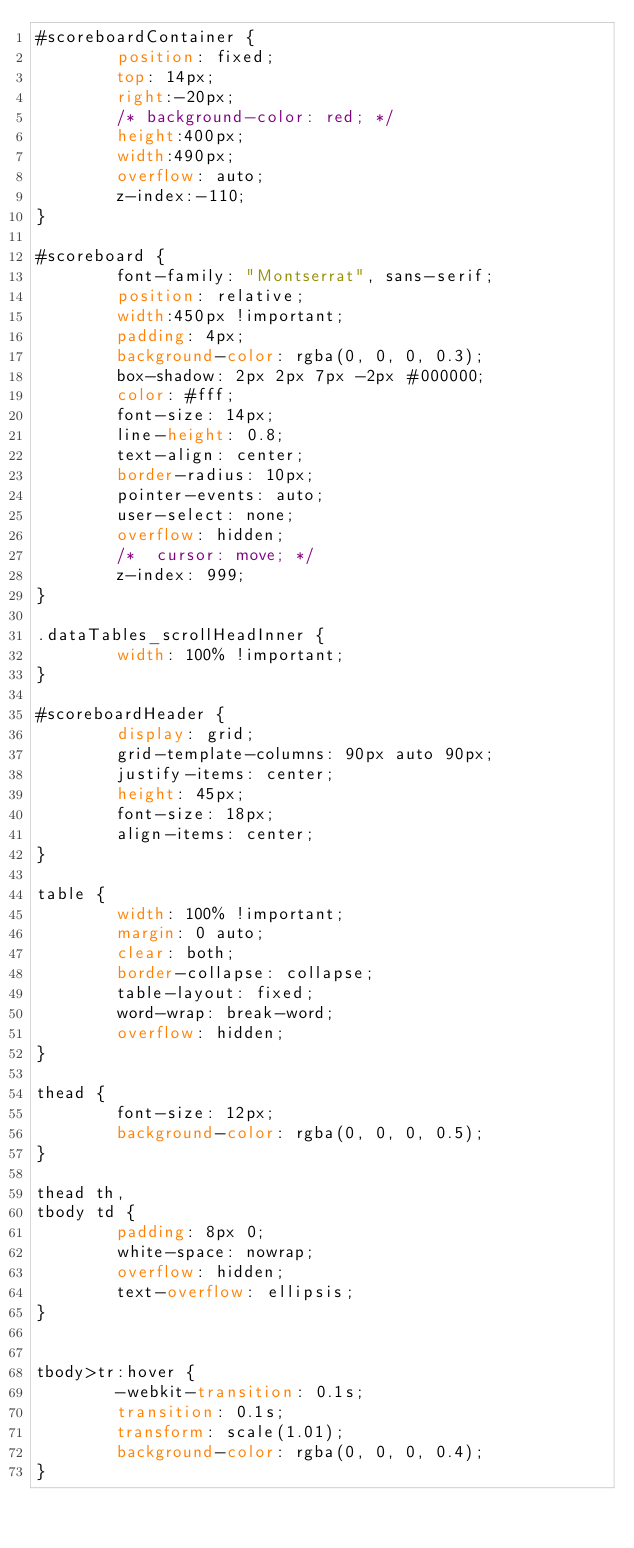Convert code to text. <code><loc_0><loc_0><loc_500><loc_500><_CSS_>#scoreboardContainer {
        position: fixed;
        top: 14px;
        right:-20px;
        /* background-color: red; */
        height:400px;
        width:490px;
        overflow: auto;
        z-index:-110;
}

#scoreboard {
        font-family: "Montserrat", sans-serif;
        position: relative;
        width:450px !important;
        padding: 4px;
        background-color: rgba(0, 0, 0, 0.3);
        box-shadow: 2px 2px 7px -2px #000000;
        color: #fff;
        font-size: 14px;
        line-height: 0.8;
        text-align: center;
        border-radius: 10px;
        pointer-events: auto;
        user-select: none;
        overflow: hidden;
        /* 	cursor: move; */
        z-index: 999;
}

.dataTables_scrollHeadInner {
        width: 100% !important;
}

#scoreboardHeader {
        display: grid;
        grid-template-columns: 90px auto 90px;
        justify-items: center;
        height: 45px;
        font-size: 18px;
        align-items: center;
}

table {
        width: 100% !important;
        margin: 0 auto;
        clear: both;
        border-collapse: collapse;
        table-layout: fixed;
        word-wrap: break-word;
        overflow: hidden;
}

thead {
        font-size: 12px;
        background-color: rgba(0, 0, 0, 0.5);
}

thead th,
tbody td {
        padding: 8px 0;
        white-space: nowrap;
        overflow: hidden;
        text-overflow: ellipsis;
}


tbody>tr:hover {
        -webkit-transition: 0.1s;
        transition: 0.1s;
        transform: scale(1.01);
        background-color: rgba(0, 0, 0, 0.4);
}</code> 